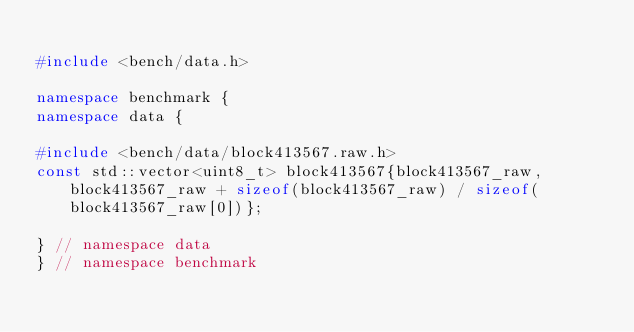<code> <loc_0><loc_0><loc_500><loc_500><_C++_>
#include <bench/data.h>

namespace benchmark {
namespace data {

#include <bench/data/block413567.raw.h>
const std::vector<uint8_t> block413567{block413567_raw, block413567_raw + sizeof(block413567_raw) / sizeof(block413567_raw[0])};

} // namespace data
} // namespace benchmark
</code> 